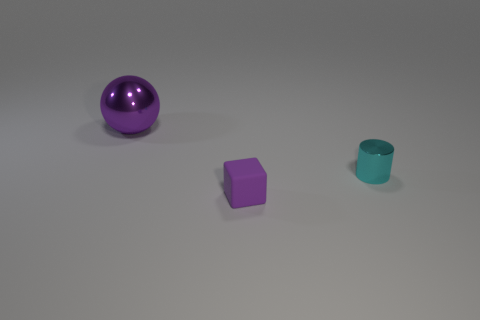Is there anything else that is made of the same material as the large purple ball?
Make the answer very short. Yes. There is a purple object that is right of the purple object that is on the left side of the small rubber cube; what is its shape?
Make the answer very short. Cube. Are there any cyan metal cylinders of the same size as the purple matte thing?
Ensure brevity in your answer.  Yes. Are there more purple rubber blocks than tiny brown metallic objects?
Your answer should be very brief. Yes. There is a cylinder that is behind the tiny cube; is its size the same as the object that is behind the small cyan cylinder?
Provide a short and direct response. No. How many objects are to the left of the small metallic cylinder and behind the tiny block?
Make the answer very short. 1. Is the number of balls less than the number of blue objects?
Offer a very short reply. No. Do the rubber thing and the metallic object that is on the right side of the small rubber object have the same size?
Offer a very short reply. Yes. What color is the small thing that is behind the purple thing that is to the right of the large purple thing?
Give a very brief answer. Cyan. What number of objects are objects right of the big metallic sphere or objects that are behind the purple rubber object?
Your answer should be compact. 3. 